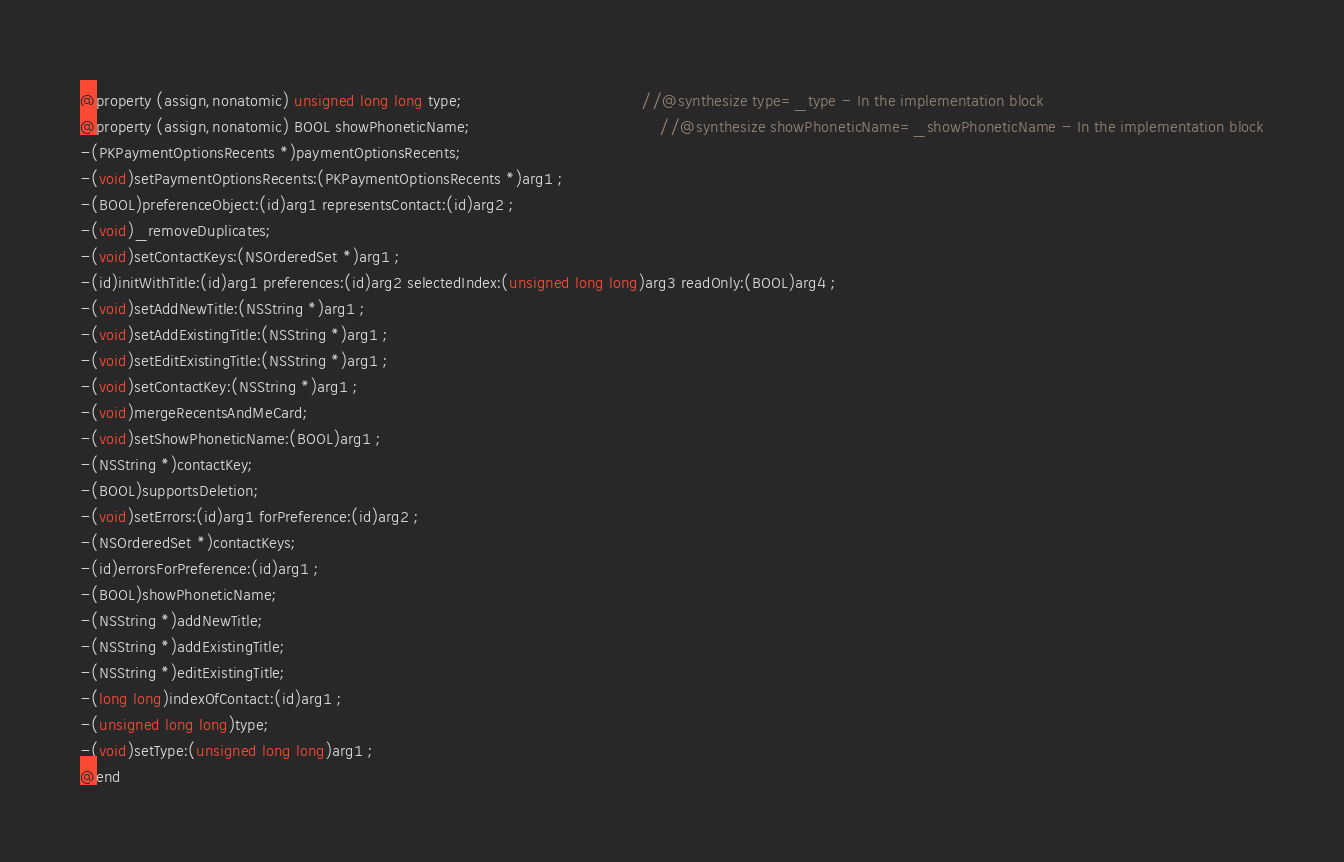<code> <loc_0><loc_0><loc_500><loc_500><_C_>@property (assign,nonatomic) unsigned long long type;                                      //@synthesize type=_type - In the implementation block
@property (assign,nonatomic) BOOL showPhoneticName;                                        //@synthesize showPhoneticName=_showPhoneticName - In the implementation block
-(PKPaymentOptionsRecents *)paymentOptionsRecents;
-(void)setPaymentOptionsRecents:(PKPaymentOptionsRecents *)arg1 ;
-(BOOL)preferenceObject:(id)arg1 representsContact:(id)arg2 ;
-(void)_removeDuplicates;
-(void)setContactKeys:(NSOrderedSet *)arg1 ;
-(id)initWithTitle:(id)arg1 preferences:(id)arg2 selectedIndex:(unsigned long long)arg3 readOnly:(BOOL)arg4 ;
-(void)setAddNewTitle:(NSString *)arg1 ;
-(void)setAddExistingTitle:(NSString *)arg1 ;
-(void)setEditExistingTitle:(NSString *)arg1 ;
-(void)setContactKey:(NSString *)arg1 ;
-(void)mergeRecentsAndMeCard;
-(void)setShowPhoneticName:(BOOL)arg1 ;
-(NSString *)contactKey;
-(BOOL)supportsDeletion;
-(void)setErrors:(id)arg1 forPreference:(id)arg2 ;
-(NSOrderedSet *)contactKeys;
-(id)errorsForPreference:(id)arg1 ;
-(BOOL)showPhoneticName;
-(NSString *)addNewTitle;
-(NSString *)addExistingTitle;
-(NSString *)editExistingTitle;
-(long long)indexOfContact:(id)arg1 ;
-(unsigned long long)type;
-(void)setType:(unsigned long long)arg1 ;
@end

</code> 